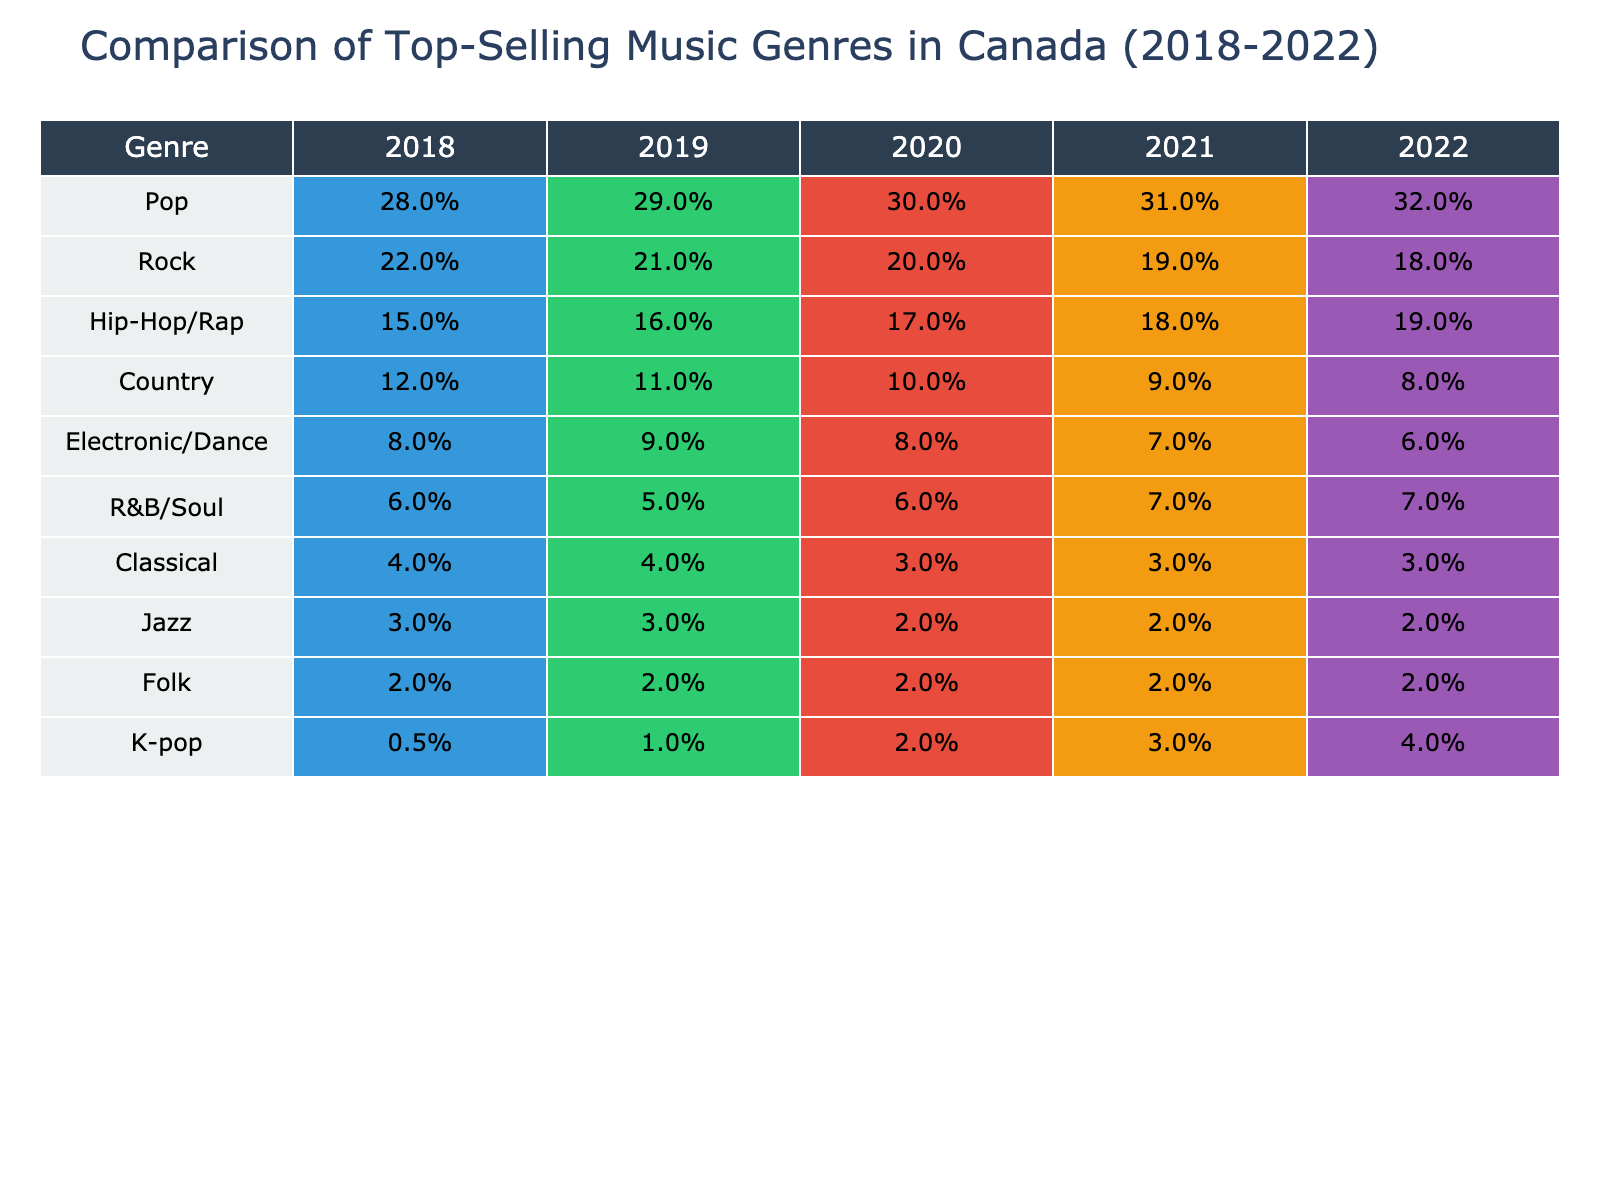What was the percentage of Hip-Hop/Rap sales in Canada in 2022? In the column for 2022, the Hip-Hop/Rap genre is listed as 19%. This is a direct retrieval from the table, so we only need to refer to that specific cell.
Answer: 19% Which genre had the highest percentage increase from 2018 to 2022? By examining the percentages for each genre in 2018 (0.5%), and in 2022 (4%), we find that K-pop had the largest increase of 3.5 percentage points (4% - 0.5%). For others like Hip-Hop/Rap, the increase is only 4% - 15% = 4%, and for Pop, the increase is 32% - 28% = 4%. Therefore, K-pop has the highest increase.
Answer: K-pop Was the percentage of Country music sales in Canada in 2019 higher than R&B/Soul sales in the same year? In 2019, Country music had 11% while R&B/Soul had 5%. Since 11% is greater than 5%, Country music sales were indeed higher in 2019 compared to R&B/Soul.
Answer: Yes What was the total percentage of sales for Pop and Rock genres combined in 2021? For 2021, Pop had 31% and Rock had 19%. Adding these together gives us 31% + 19% = 50%. This is a simple addition operation to find the total combined percentage for these genres.
Answer: 50% In which genre's sales did we observe a decline over the five years? Looking at the data, Rock's sales have decreased from 22% in 2018 to 18% in 2022, which is a decline. Country also shows a decline from 12% to 8%. Other genres either increased or remained stable. Therefore, Rock and Country are the genres with declining sales over this period.
Answer: Yes, Rock and Country What is the average percentage of Electronic/Dance music sales from 2018 to 2022? The percentages for Electronic/Dance over the years are 8%, 9%, 8%, 7%, and 6%. To find the average, we sum these values: 8 + 9 + 8 + 7 + 6 = 38. Then we divide by the number of years, which is 5. The average is 38/5 = 7.6%.
Answer: 7.6% How much did R&B/Soul's sales increase from 2018 to 2022? R&B/Soul had a percentage of 6% in 2018 and 7% in 2022. To find the increase, we subtract 6% from 7%, which gives us an increase of 1%. This is a simple subtraction to find the difference over the 5 years.
Answer: 1% Which genre maintained the same percentage sales throughout the five years? In the data, Classical and Jazz each held at 4% and 3%, respectively, from 2018 to 2022, showing no change. Thus, these genres maintained the same percentage over the five years according to the table.
Answer: Classical and Jazz 